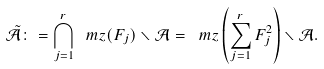<formula> <loc_0><loc_0><loc_500><loc_500>\tilde { \mathcal { A } } \colon = \bigcap _ { j = 1 } ^ { r } \ m z ( F _ { j } ) \smallsetminus { \mathcal { A } } = \ m z \left ( \sum _ { j = 1 } ^ { r } F _ { j } ^ { 2 } \right ) \smallsetminus { \mathcal { A } } .</formula> 